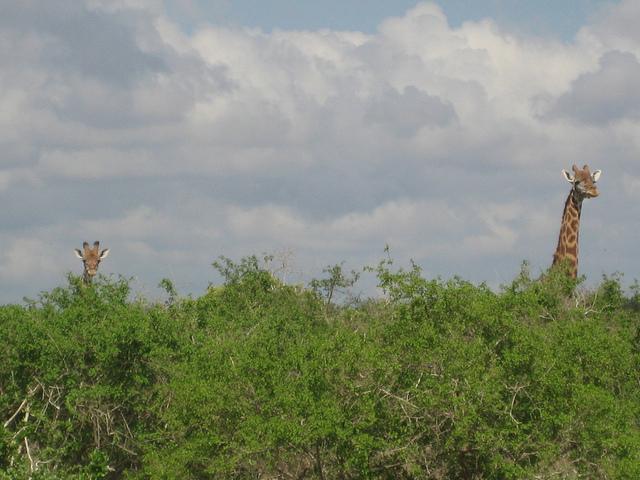Is the background blurry?
Give a very brief answer. No. What is the weather?
Short answer required. Cloudy. How's the weather?
Keep it brief. Cloudy. Are the crop fields lush and verdant?
Write a very short answer. Yes. Is the last giraffe looking at the camera?
Be succinct. Yes. Where are the giraffes?
Answer briefly. Forest. How many animals are in this photo?
Quick response, please. 2. Is the animal large?
Give a very brief answer. Yes. Is there anything flying in the picture?
Write a very short answer. No. Is it sunny out?
Short answer required. No. What season is this scene in?
Give a very brief answer. Summer. 